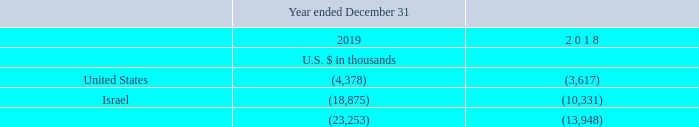NOTE 13 - TAXES ON INCOME (Cont.)
D. Loss from continuing operations, before taxes on income, consists of the following:
E. Due to the Company’s cumulative losses, the effect of ASC 740 as codified from ASC 740-10 is not material.
What is the loss from continuing operations, before taxes on income, in the United States in 2019 and 2018 respectively?
Answer scale should be: thousand. 4,378, 3,617. What is the loss from continuing operations, before taxes on income, in Israel in 2019 and 2018 respectively?
Answer scale should be: thousand. 18,875, 10,331. What is the total loss from continuing operations, before taxes on income, for the year ended December 31, 2019?
Answer scale should be: thousand. 23,253. What is the change in loss from continuing operations, before taxes on income, in U.S. from 2018 to 2019?
Answer scale should be: thousand. 4,378-3,617
Answer: 761. What is the percentage change in the total loss from continuing operations, before taxes on income, from 2018 to 2019?
Answer scale should be: percent. (23,253-13,948)/13,948
Answer: 66.71. What is the percentage of Israel's loss from continuing operations, before taxes on income, for the year ended 2019?
Answer scale should be: percent. 18,875/23,253
Answer: 81.17. 